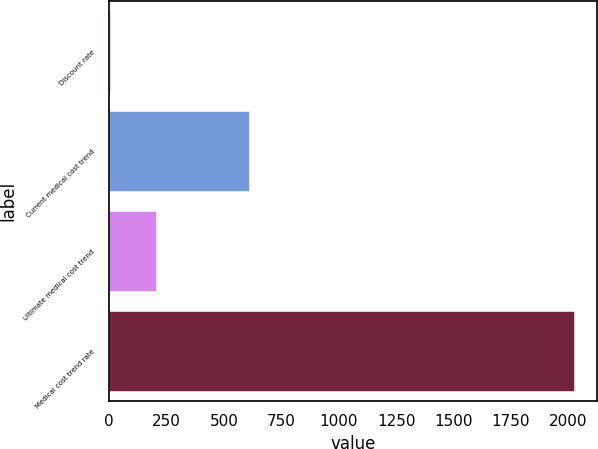Convert chart to OTSL. <chart><loc_0><loc_0><loc_500><loc_500><bar_chart><fcel>Discount rate<fcel>Current medical cost trend<fcel>Ultimate medical cost trend<fcel>Medical cost trend rate<nl><fcel>3.46<fcel>609.91<fcel>205.61<fcel>2025<nl></chart> 